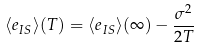<formula> <loc_0><loc_0><loc_500><loc_500>\langle e _ { I S } \rangle ( T ) = \langle e _ { I S } \rangle ( \infty ) - \frac { \sigma ^ { 2 } } { 2 T }</formula> 